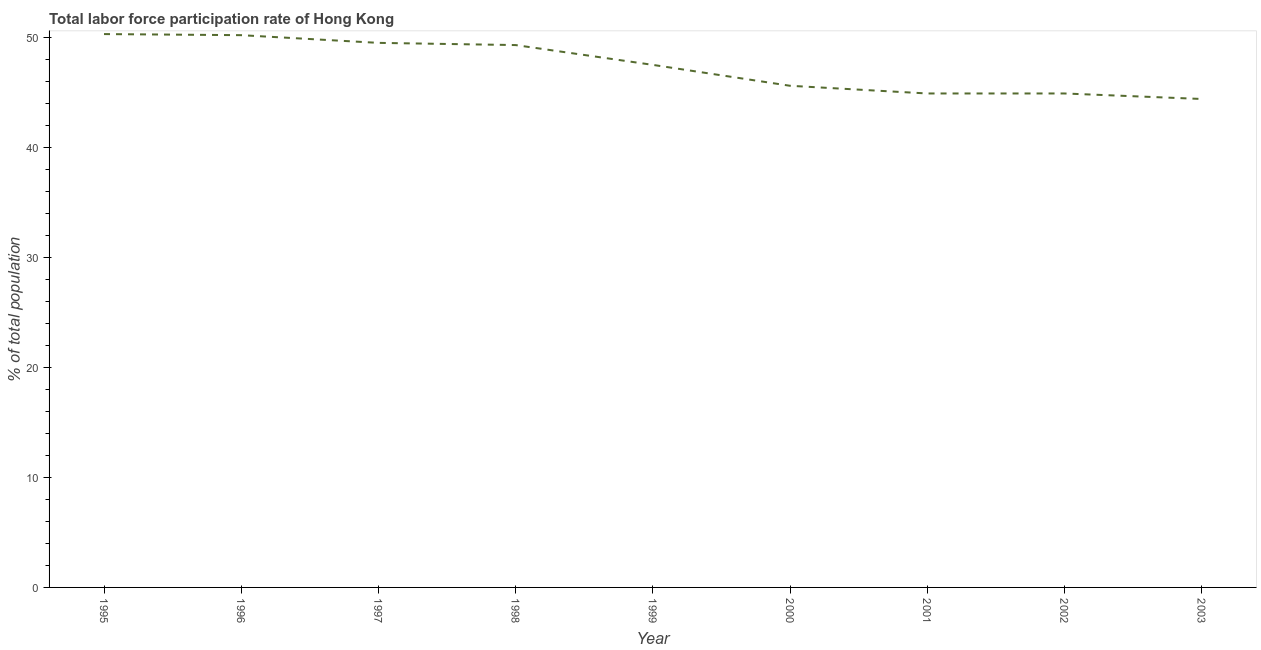What is the total labor force participation rate in 1995?
Offer a very short reply. 50.3. Across all years, what is the maximum total labor force participation rate?
Your answer should be very brief. 50.3. Across all years, what is the minimum total labor force participation rate?
Ensure brevity in your answer.  44.4. In which year was the total labor force participation rate maximum?
Your answer should be compact. 1995. What is the sum of the total labor force participation rate?
Your response must be concise. 426.6. What is the difference between the total labor force participation rate in 2001 and 2002?
Offer a terse response. 0. What is the average total labor force participation rate per year?
Give a very brief answer. 47.4. What is the median total labor force participation rate?
Give a very brief answer. 47.5. In how many years, is the total labor force participation rate greater than 46 %?
Keep it short and to the point. 5. What is the ratio of the total labor force participation rate in 2001 to that in 2003?
Keep it short and to the point. 1.01. Is the total labor force participation rate in 2001 less than that in 2002?
Your answer should be compact. No. What is the difference between the highest and the second highest total labor force participation rate?
Your answer should be very brief. 0.1. Is the sum of the total labor force participation rate in 1997 and 2002 greater than the maximum total labor force participation rate across all years?
Your answer should be very brief. Yes. What is the difference between the highest and the lowest total labor force participation rate?
Your answer should be very brief. 5.9. In how many years, is the total labor force participation rate greater than the average total labor force participation rate taken over all years?
Give a very brief answer. 5. Does the total labor force participation rate monotonically increase over the years?
Offer a terse response. No. How many lines are there?
Your answer should be very brief. 1. What is the difference between two consecutive major ticks on the Y-axis?
Your answer should be very brief. 10. Are the values on the major ticks of Y-axis written in scientific E-notation?
Your response must be concise. No. Does the graph contain grids?
Your response must be concise. No. What is the title of the graph?
Keep it short and to the point. Total labor force participation rate of Hong Kong. What is the label or title of the Y-axis?
Keep it short and to the point. % of total population. What is the % of total population of 1995?
Keep it short and to the point. 50.3. What is the % of total population in 1996?
Offer a terse response. 50.2. What is the % of total population of 1997?
Offer a terse response. 49.5. What is the % of total population in 1998?
Give a very brief answer. 49.3. What is the % of total population of 1999?
Give a very brief answer. 47.5. What is the % of total population of 2000?
Ensure brevity in your answer.  45.6. What is the % of total population of 2001?
Keep it short and to the point. 44.9. What is the % of total population of 2002?
Keep it short and to the point. 44.9. What is the % of total population of 2003?
Ensure brevity in your answer.  44.4. What is the difference between the % of total population in 1995 and 1997?
Your response must be concise. 0.8. What is the difference between the % of total population in 1995 and 2000?
Provide a short and direct response. 4.7. What is the difference between the % of total population in 1995 and 2001?
Your answer should be compact. 5.4. What is the difference between the % of total population in 1995 and 2002?
Ensure brevity in your answer.  5.4. What is the difference between the % of total population in 1996 and 2000?
Make the answer very short. 4.6. What is the difference between the % of total population in 1996 and 2003?
Keep it short and to the point. 5.8. What is the difference between the % of total population in 1997 and 2000?
Make the answer very short. 3.9. What is the difference between the % of total population in 1997 and 2001?
Your answer should be compact. 4.6. What is the difference between the % of total population in 1998 and 1999?
Provide a short and direct response. 1.8. What is the difference between the % of total population in 1998 and 2001?
Ensure brevity in your answer.  4.4. What is the difference between the % of total population in 1998 and 2002?
Offer a terse response. 4.4. What is the difference between the % of total population in 1998 and 2003?
Make the answer very short. 4.9. What is the difference between the % of total population in 1999 and 2000?
Offer a very short reply. 1.9. What is the difference between the % of total population in 1999 and 2001?
Provide a succinct answer. 2.6. What is the difference between the % of total population in 1999 and 2003?
Your answer should be compact. 3.1. What is the difference between the % of total population in 2000 and 2002?
Your answer should be compact. 0.7. What is the difference between the % of total population in 2001 and 2002?
Ensure brevity in your answer.  0. What is the difference between the % of total population in 2001 and 2003?
Your response must be concise. 0.5. What is the difference between the % of total population in 2002 and 2003?
Provide a succinct answer. 0.5. What is the ratio of the % of total population in 1995 to that in 1997?
Provide a succinct answer. 1.02. What is the ratio of the % of total population in 1995 to that in 1998?
Keep it short and to the point. 1.02. What is the ratio of the % of total population in 1995 to that in 1999?
Keep it short and to the point. 1.06. What is the ratio of the % of total population in 1995 to that in 2000?
Give a very brief answer. 1.1. What is the ratio of the % of total population in 1995 to that in 2001?
Provide a succinct answer. 1.12. What is the ratio of the % of total population in 1995 to that in 2002?
Your answer should be very brief. 1.12. What is the ratio of the % of total population in 1995 to that in 2003?
Your answer should be very brief. 1.13. What is the ratio of the % of total population in 1996 to that in 1999?
Offer a terse response. 1.06. What is the ratio of the % of total population in 1996 to that in 2000?
Offer a very short reply. 1.1. What is the ratio of the % of total population in 1996 to that in 2001?
Offer a terse response. 1.12. What is the ratio of the % of total population in 1996 to that in 2002?
Ensure brevity in your answer.  1.12. What is the ratio of the % of total population in 1996 to that in 2003?
Your answer should be compact. 1.13. What is the ratio of the % of total population in 1997 to that in 1999?
Give a very brief answer. 1.04. What is the ratio of the % of total population in 1997 to that in 2000?
Provide a succinct answer. 1.09. What is the ratio of the % of total population in 1997 to that in 2001?
Keep it short and to the point. 1.1. What is the ratio of the % of total population in 1997 to that in 2002?
Give a very brief answer. 1.1. What is the ratio of the % of total population in 1997 to that in 2003?
Offer a terse response. 1.11. What is the ratio of the % of total population in 1998 to that in 1999?
Your response must be concise. 1.04. What is the ratio of the % of total population in 1998 to that in 2000?
Your answer should be compact. 1.08. What is the ratio of the % of total population in 1998 to that in 2001?
Provide a short and direct response. 1.1. What is the ratio of the % of total population in 1998 to that in 2002?
Offer a very short reply. 1.1. What is the ratio of the % of total population in 1998 to that in 2003?
Give a very brief answer. 1.11. What is the ratio of the % of total population in 1999 to that in 2000?
Your answer should be compact. 1.04. What is the ratio of the % of total population in 1999 to that in 2001?
Your response must be concise. 1.06. What is the ratio of the % of total population in 1999 to that in 2002?
Your answer should be very brief. 1.06. What is the ratio of the % of total population in 1999 to that in 2003?
Your answer should be very brief. 1.07. What is the ratio of the % of total population in 2000 to that in 2003?
Your answer should be compact. 1.03. What is the ratio of the % of total population in 2001 to that in 2003?
Offer a terse response. 1.01. What is the ratio of the % of total population in 2002 to that in 2003?
Ensure brevity in your answer.  1.01. 